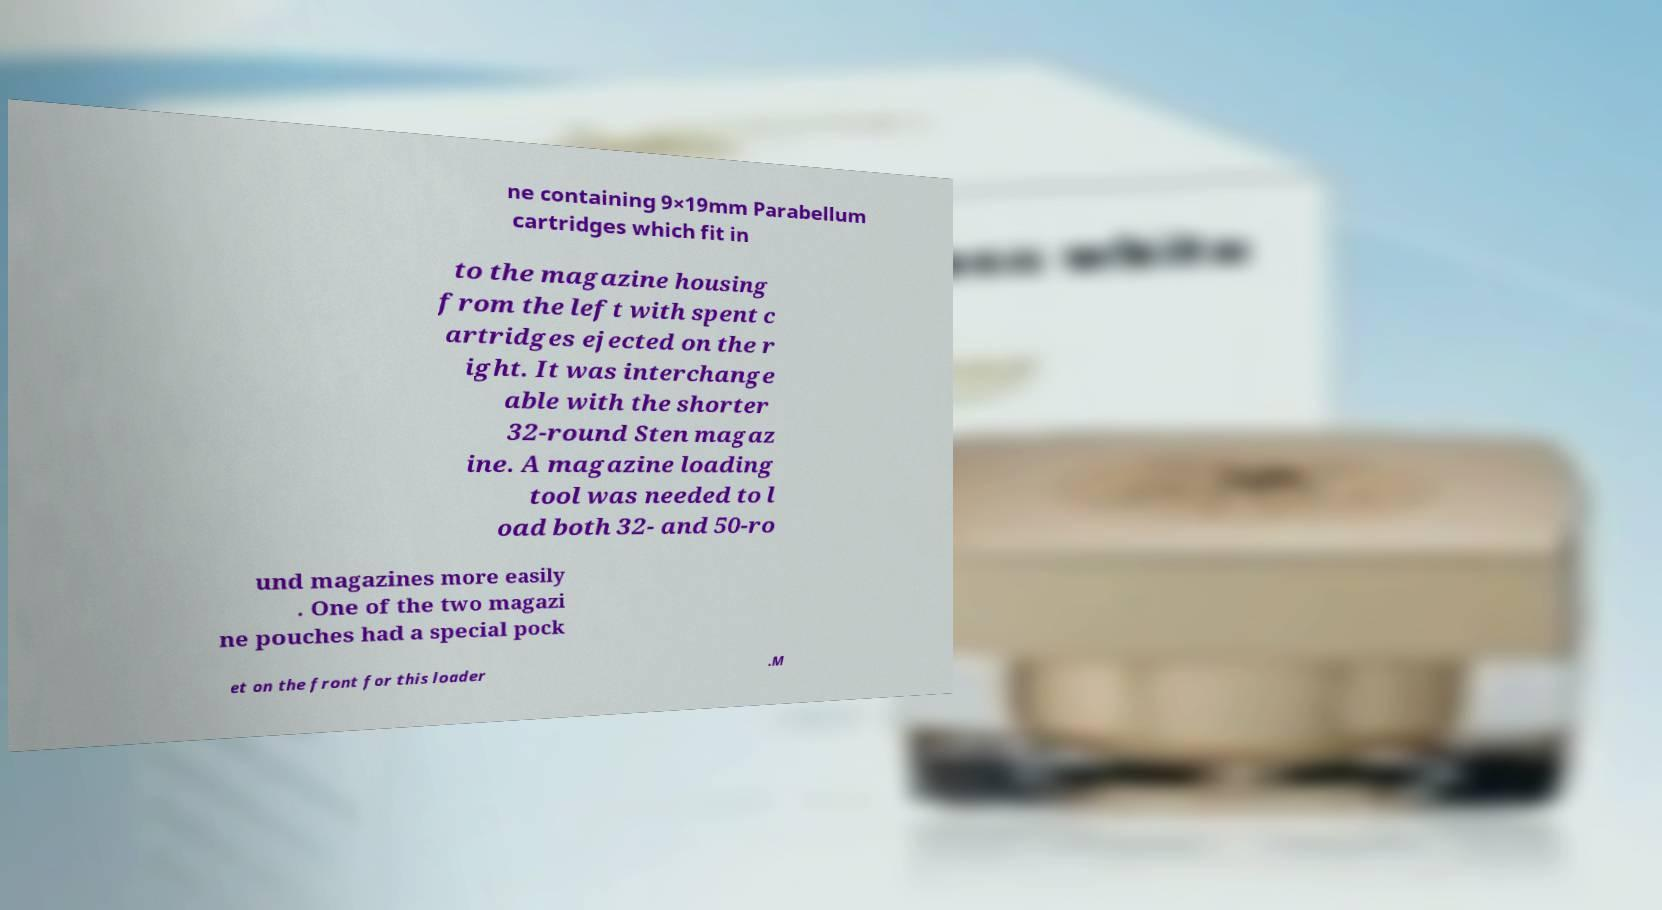Could you assist in decoding the text presented in this image and type it out clearly? ne containing 9×19mm Parabellum cartridges which fit in to the magazine housing from the left with spent c artridges ejected on the r ight. It was interchange able with the shorter 32-round Sten magaz ine. A magazine loading tool was needed to l oad both 32- and 50-ro und magazines more easily . One of the two magazi ne pouches had a special pock et on the front for this loader .M 